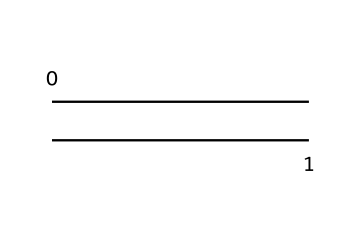What is the name of this monomer? The chemical structure shown is ethylene, which is a two-carbon alkene with a double bond between them.
Answer: ethylene How many carbon atoms are in this structure? The structure depicts two carbon atoms, as represented by the two 'C' in the SMILES notation.
Answer: 2 How many double bonds are present in this molecule? In the structure, there is a single double bond indicated by the '=' sign between the two carbon atoms.
Answer: 1 What is the total number of hydrogen atoms bonded to the carbon atoms in ethylene? Each carbon in ethylene forms two bonds with hydrogen atoms as it has one double bond with another carbon; thus, there are a total of four hydrogen atoms.
Answer: 4 What type of chemical is ethylene classified as? Ethylene is classified as an alkene because it contains a carbon-carbon double bond.
Answer: alkene What is the hybridization of the carbon atoms in ethylene? The hybridization of the carbon atoms involved in the double bond is sp2, which is determined by the arrangement of the bonds around each carbon.
Answer: sp2 How many pi bonds are present in ethylene? Ethylene contains one pi bond, which arises from the double bond between the two carbon atoms; a double bond consists of one sigma bond and one pi bond.
Answer: 1 